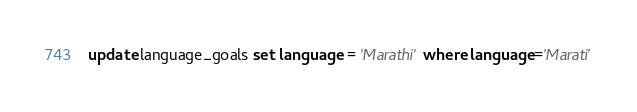<code> <loc_0><loc_0><loc_500><loc_500><_SQL_>
update language_goals set language = 'Marathi' where language='Marati'
</code> 